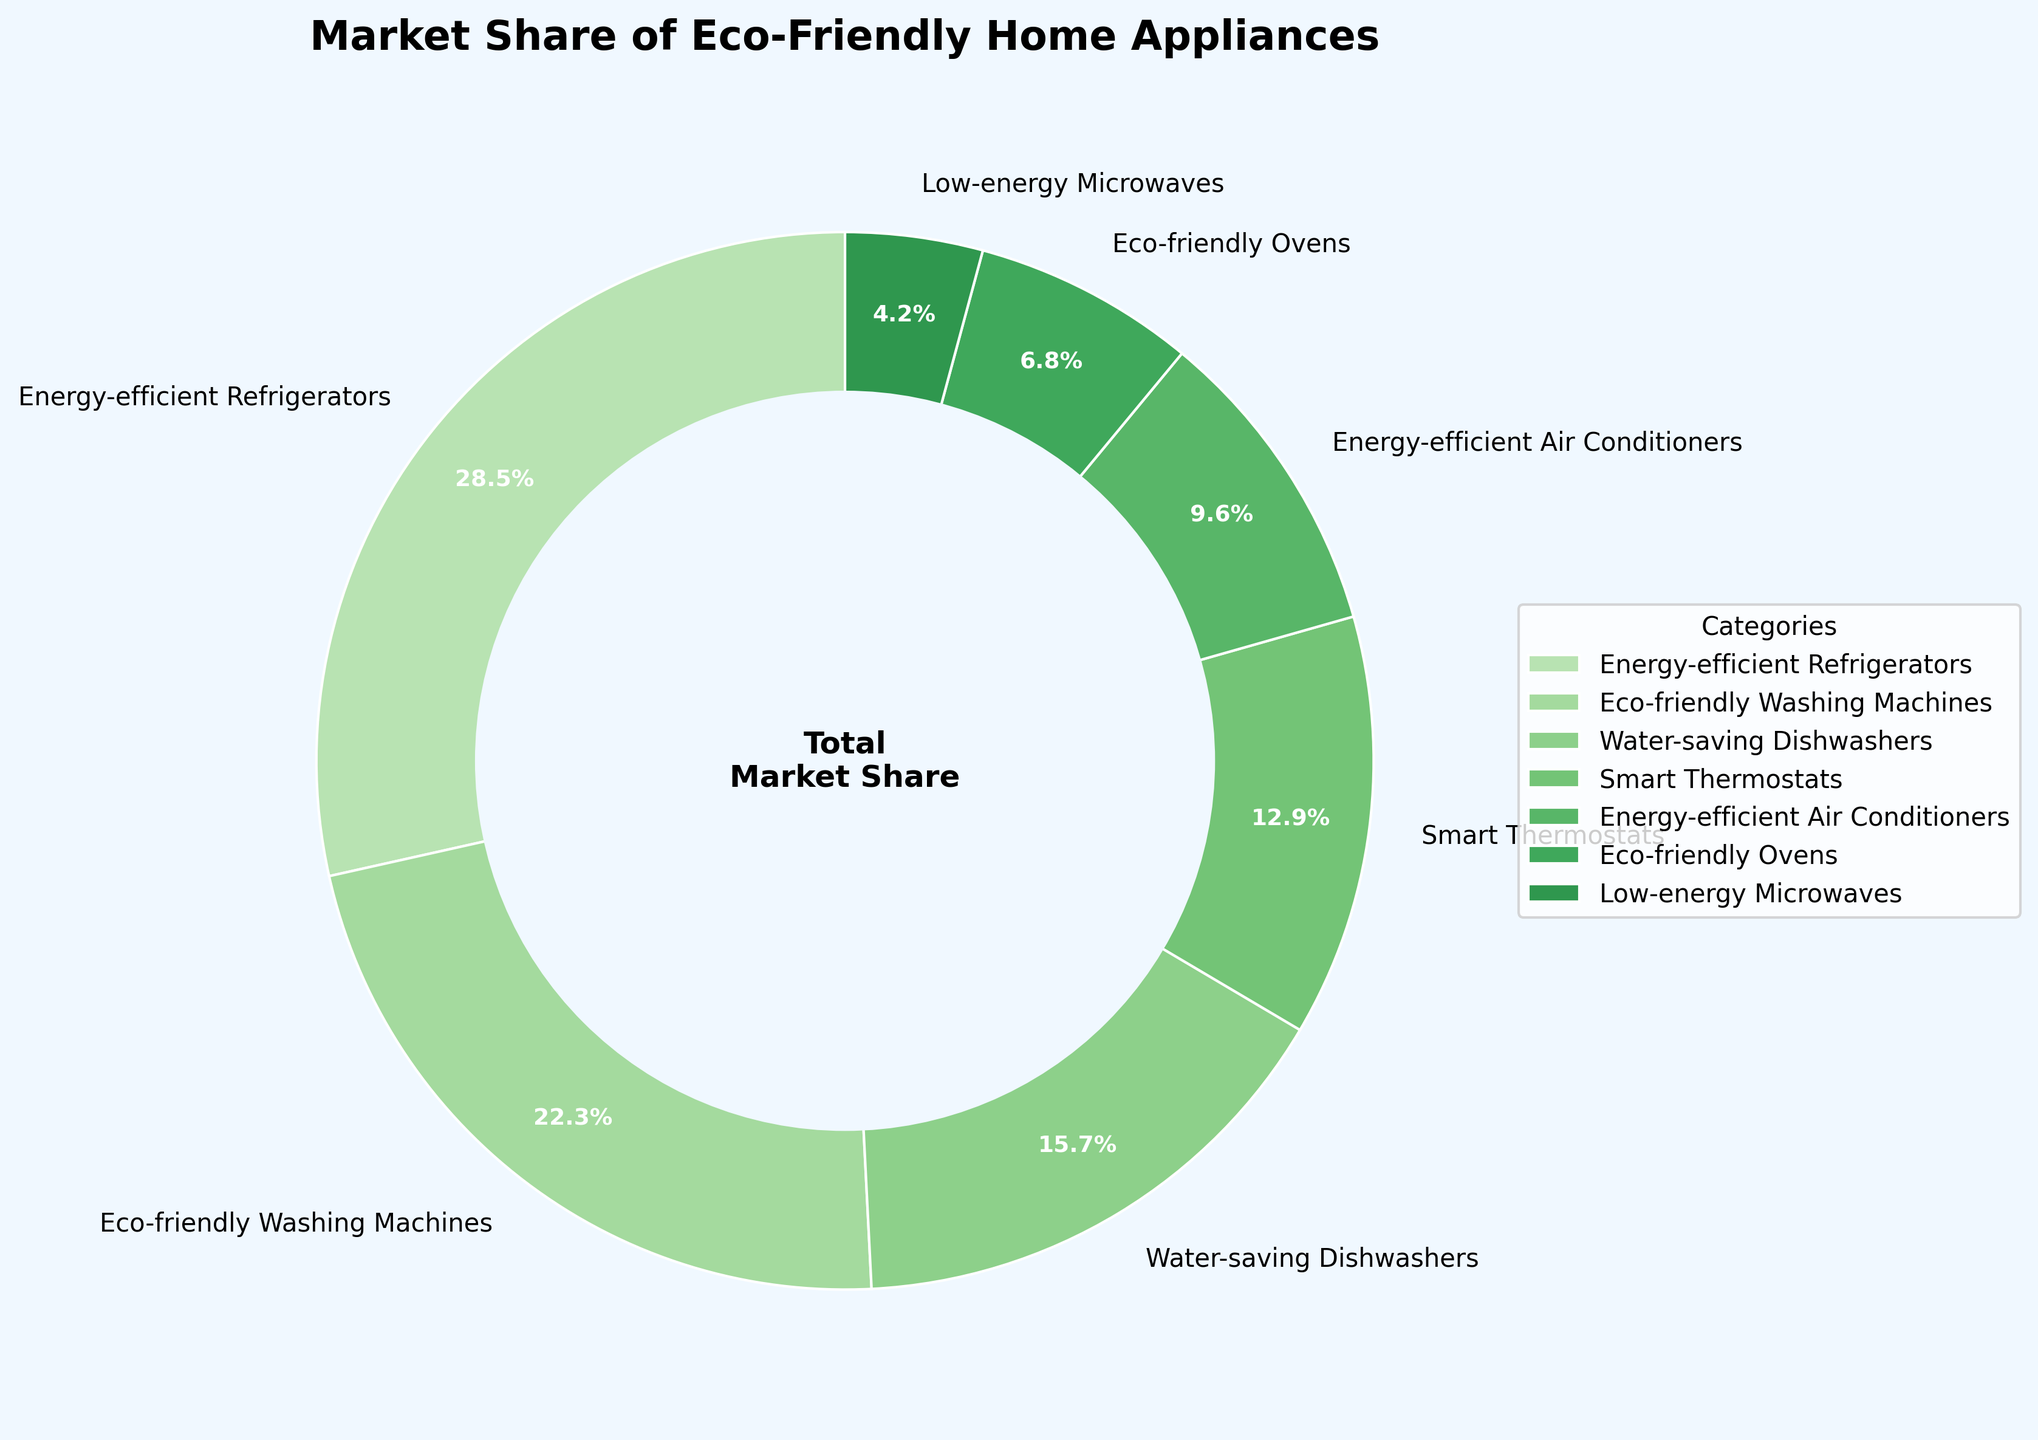What's the total market share of Energy-efficient Refrigerators and Eco-friendly Washing Machines combined? The market share for Energy-efficient Refrigerators is 28.5% and for Eco-friendly Washing Machines is 22.3%. Adding these values together gives 28.5 + 22.3 = 50.8%
Answer: 50.8% What is the difference in market share between Smart Thermostats and Low-energy Microwaves? The market share for Smart Thermostats is 12.9% and for Low-energy Microwaves is 4.2%. Subtracting these values gives 12.9 - 4.2 = 8.7%
Answer: 8.7% Which category has the smallest market share? The category with the smallest market share as per the legend and chart is Low-energy Microwaves with a market share of 4.2%
Answer: Low-energy Microwaves Among Energy-efficient Air Conditioners and Eco-friendly Ovens, which one has a higher market share? Energy-efficient Air Conditioners have a market share of 9.6%, while Eco-friendly Ovens have a market share of 6.8%. Thus, Energy-efficient Air Conditioners have a higher market share than Eco-friendly Ovens
Answer: Energy-efficient Air Conditioners What is the average market share of Water-saving Dishwashers, Smart Thermostats, and Eco-friendly Ovens? The market shares are: Water-saving Dishwashers (15.7%), Smart Thermostats (12.9%), and Eco-friendly Ovens (6.8%). The sum of these is 15.7 + 12.9 + 6.8 = 35.4%. Dividing by 3 gives an average of 35.4 / 3 ≈ 11.8%
Answer: 11.8% If you combine the market shares of the three smallest categories, what is their total market share? The three smallest categories are Low-energy Microwaves (4.2%), Eco-friendly Ovens (6.8%), and Energy-efficient Air Conditioners (9.6%). Adding these values gives 4.2 + 6.8 + 9.6 = 20.6%
Answer: 20.6% Which has a greater market share, Water-saving Dishwashers or Smart Thermostats? Water-saving Dishwashers have a market share of 15.7%, while Smart Thermostats have a market share of 12.9%. Therefore, Water-saving Dishwashers have a greater market share
Answer: Water-saving Dishwashers Does any category have a market share more than double that of Eco-friendly Ovens? Eco-friendly Ovens have a market share of 6.8%. Double this value is 13.6%. Categories with a market share greater than 13.6% are Energy-efficient Refrigerators (28.5%) and Eco-friendly Washing Machines (22.3%)
Answer: Yes 